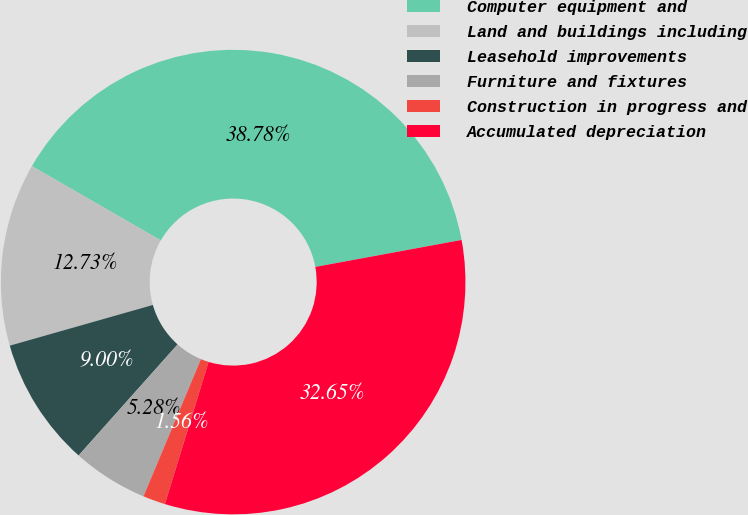Convert chart to OTSL. <chart><loc_0><loc_0><loc_500><loc_500><pie_chart><fcel>Computer equipment and<fcel>Land and buildings including<fcel>Leasehold improvements<fcel>Furniture and fixtures<fcel>Construction in progress and<fcel>Accumulated depreciation<nl><fcel>38.78%<fcel>12.73%<fcel>9.0%<fcel>5.28%<fcel>1.56%<fcel>32.65%<nl></chart> 